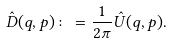<formula> <loc_0><loc_0><loc_500><loc_500>\hat { D } ( q , p ) \colon = \frac { 1 } { 2 \pi } \hat { U } ( q , p ) .</formula> 